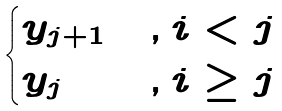Convert formula to latex. <formula><loc_0><loc_0><loc_500><loc_500>\begin{cases} y _ { j + 1 } & , i < j \\ y _ { j } & , i \geq j \end{cases}</formula> 